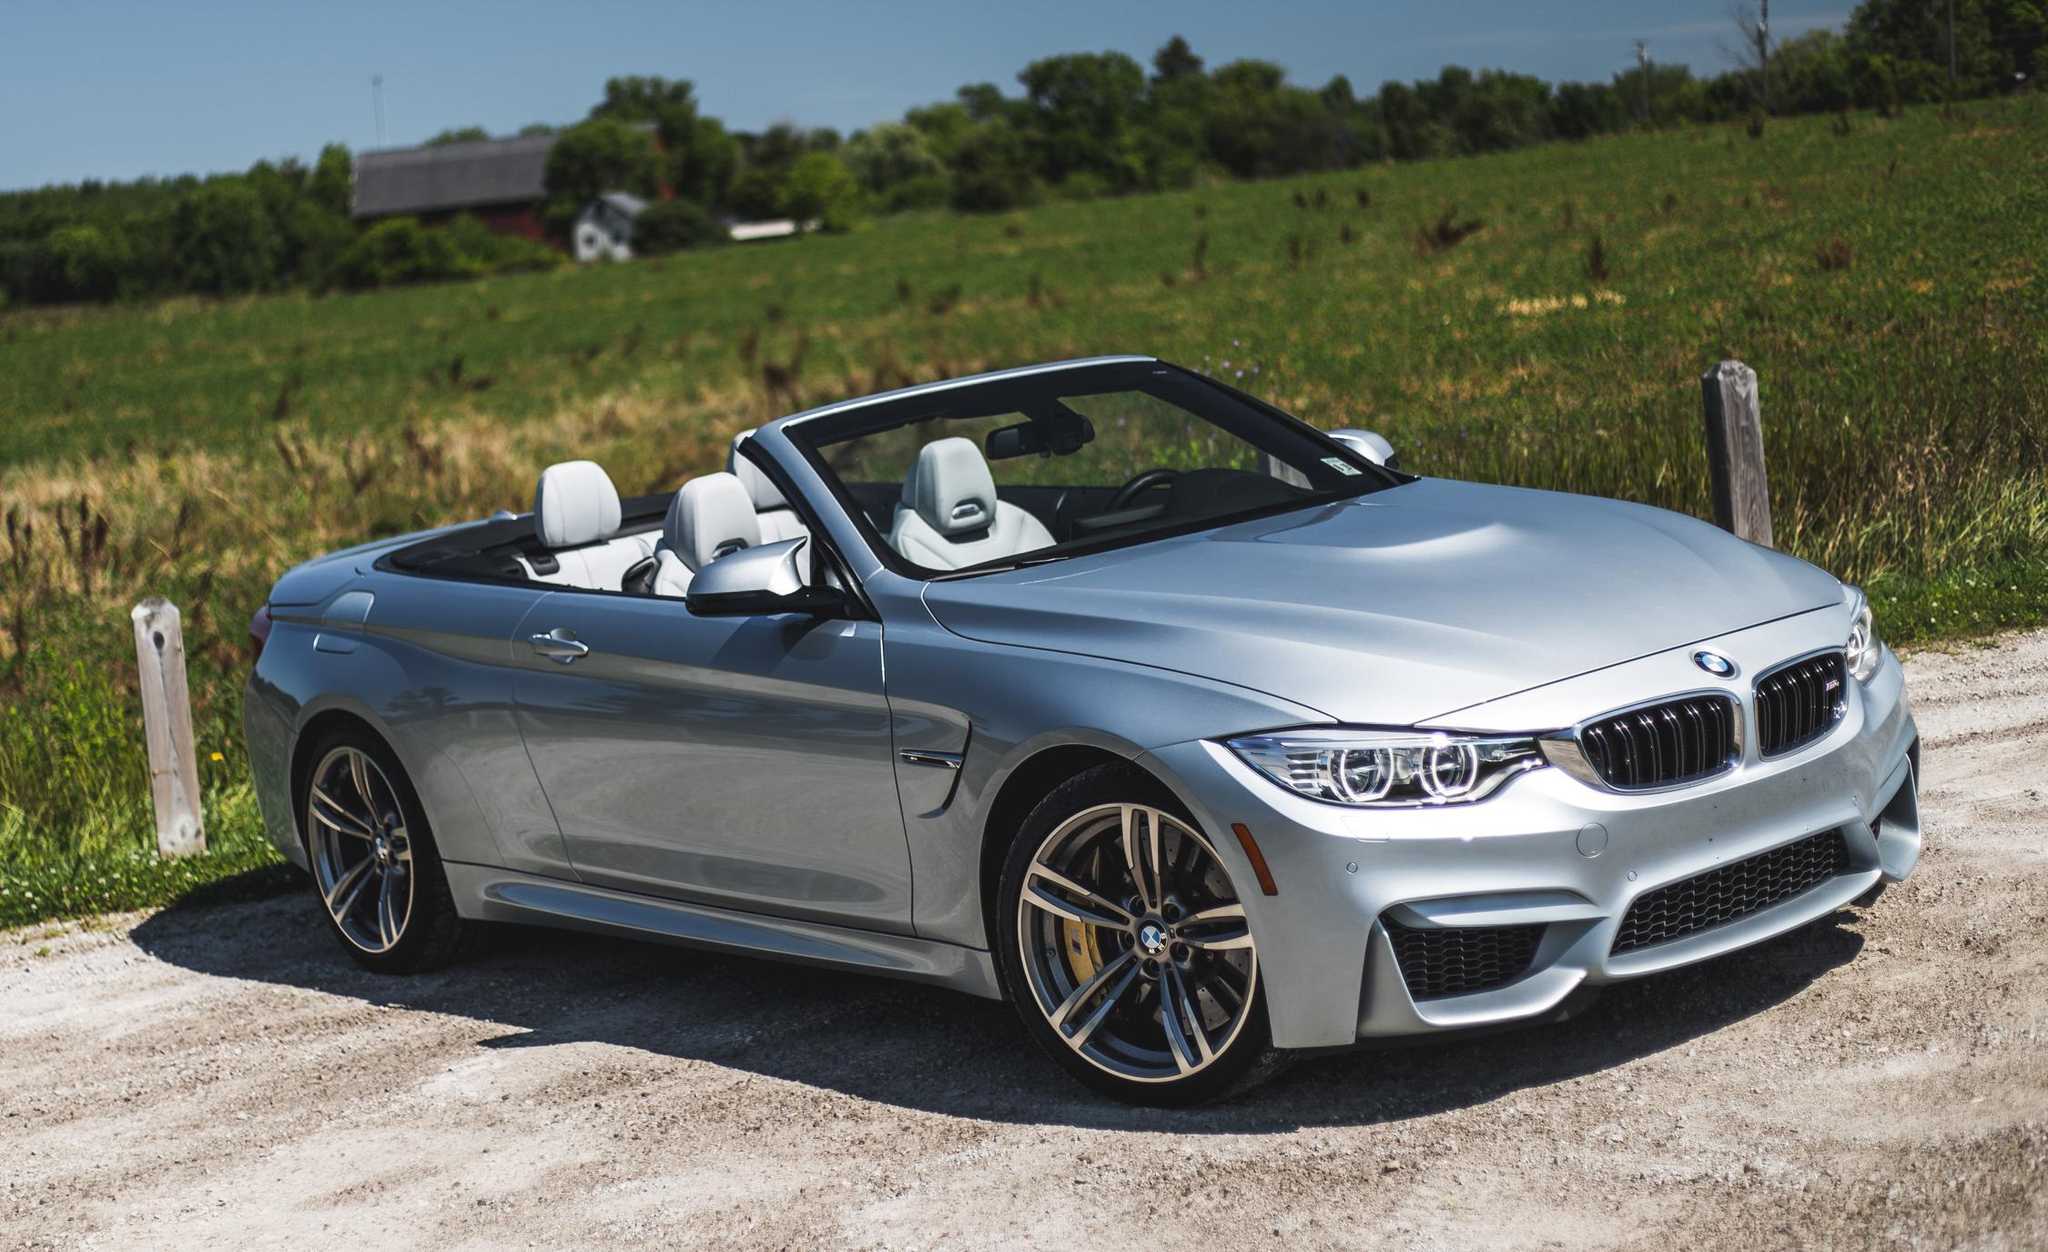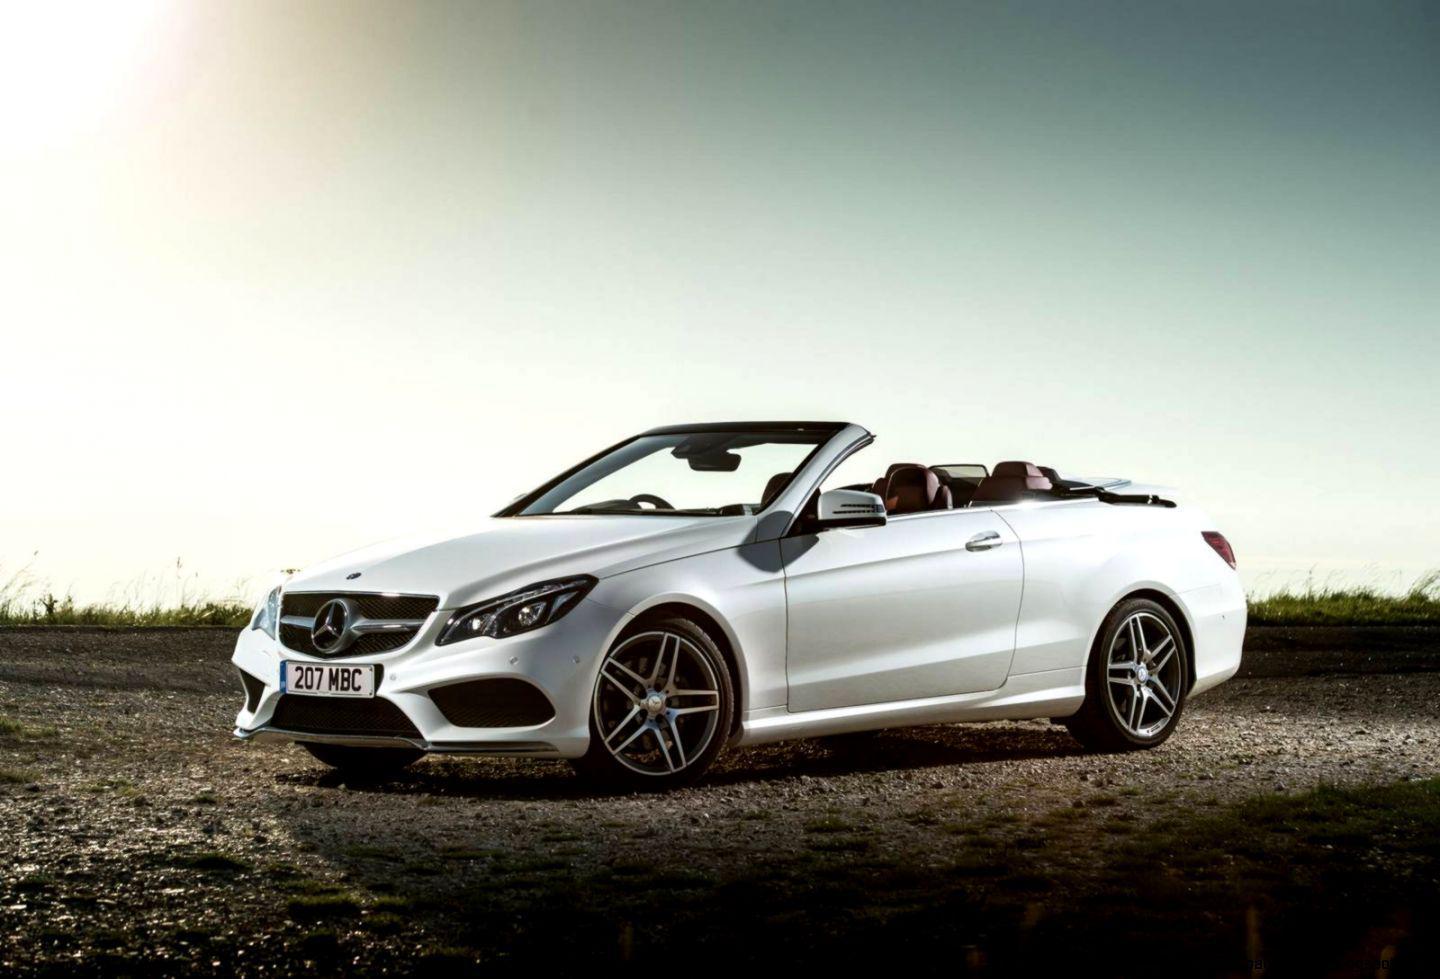The first image is the image on the left, the second image is the image on the right. For the images displayed, is the sentence "Two convertibles with visible headrests, one of them with chrome wheels, are parked and angled in the same direction." factually correct? Answer yes or no. No. The first image is the image on the left, the second image is the image on the right. Assess this claim about the two images: "The cars in the left and right images are each turned leftward, and one car is pictured in front of water and peaks of land.". Correct or not? Answer yes or no. No. 